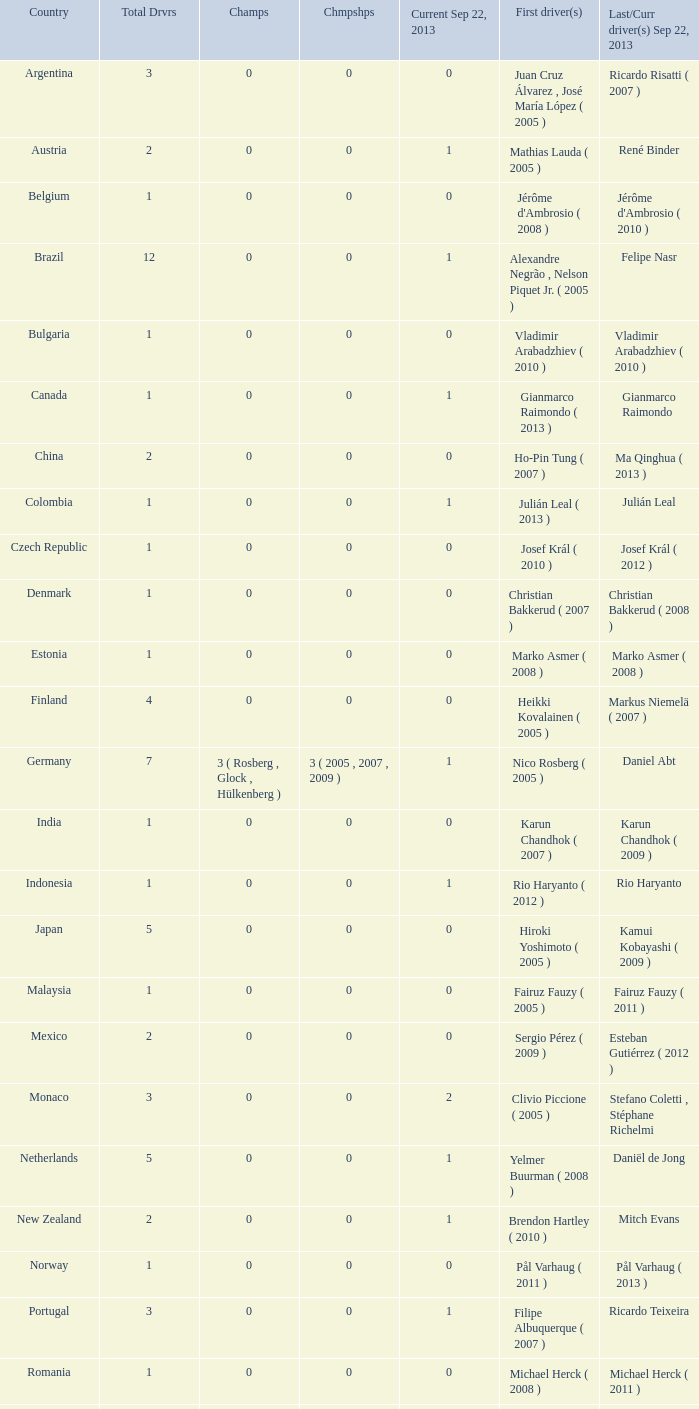How many champions were there when the first driver was hiroki yoshimoto ( 2005 )? 0.0. 